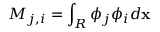Convert formula to latex. <formula><loc_0><loc_0><loc_500><loc_500>M _ { j , i } = \int _ { R } \phi _ { j } \phi _ { i } d \mathbf x</formula> 